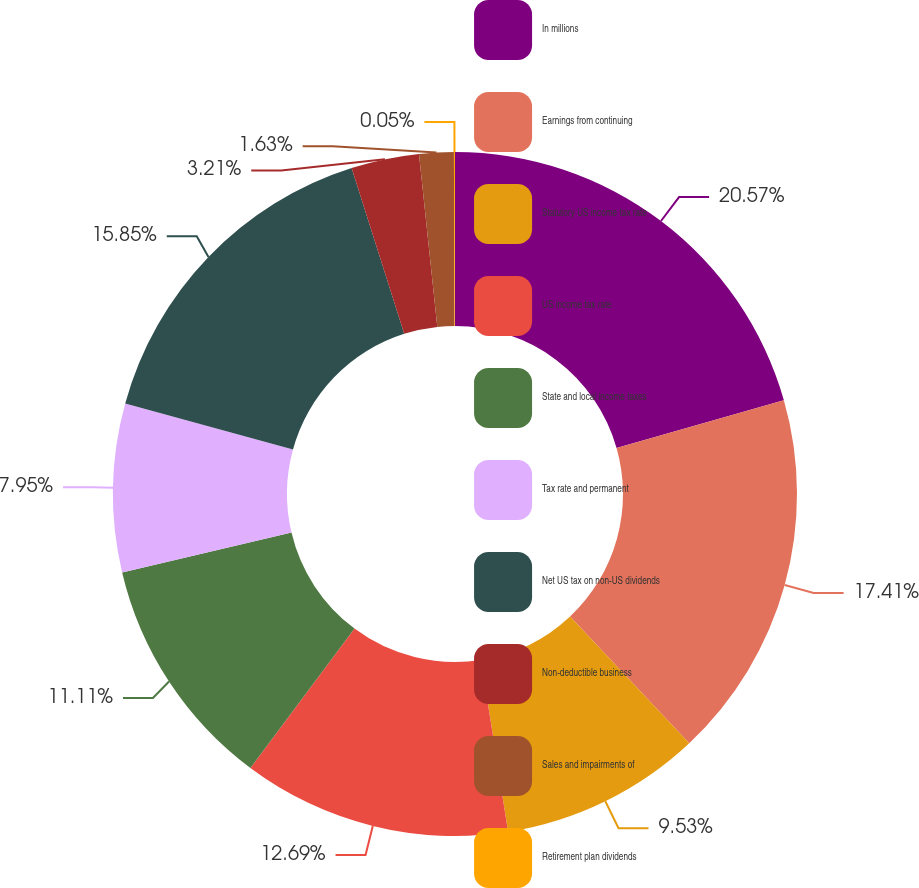Convert chart to OTSL. <chart><loc_0><loc_0><loc_500><loc_500><pie_chart><fcel>In millions<fcel>Earnings from continuing<fcel>Statutory US income tax rate<fcel>US income tax rate<fcel>State and local income taxes<fcel>Tax rate and permanent<fcel>Net US tax on non-US dividends<fcel>Non-deductible business<fcel>Sales and impairments of<fcel>Retirement plan dividends<nl><fcel>20.58%<fcel>17.42%<fcel>9.53%<fcel>12.69%<fcel>11.11%<fcel>7.95%<fcel>15.85%<fcel>3.21%<fcel>1.63%<fcel>0.05%<nl></chart> 